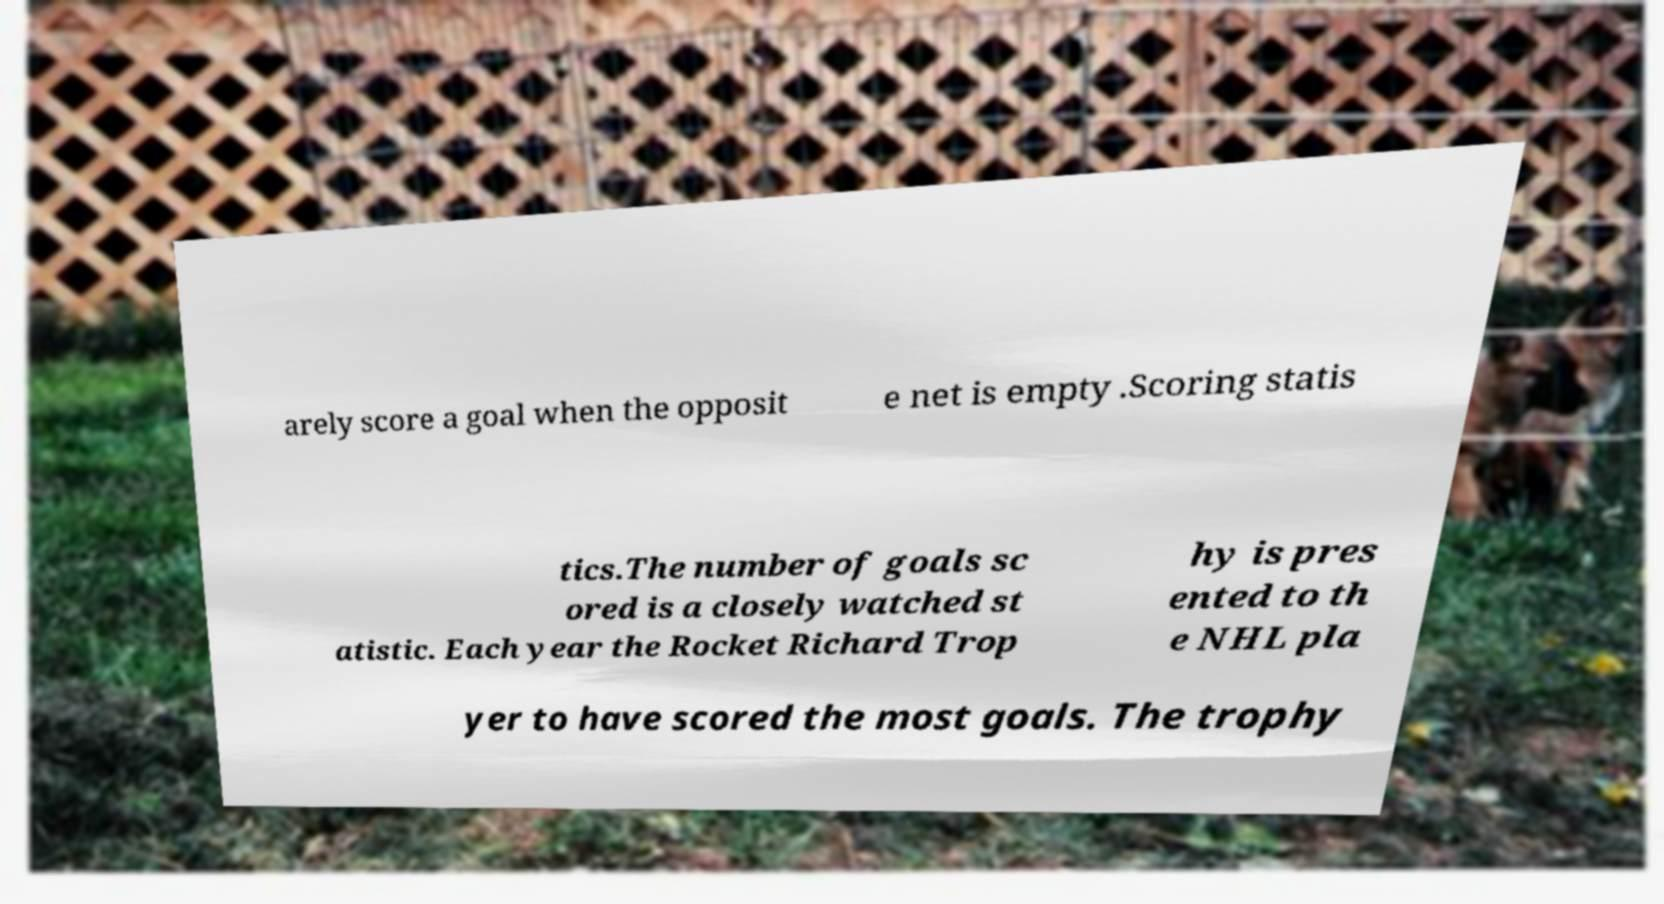There's text embedded in this image that I need extracted. Can you transcribe it verbatim? arely score a goal when the opposit e net is empty .Scoring statis tics.The number of goals sc ored is a closely watched st atistic. Each year the Rocket Richard Trop hy is pres ented to th e NHL pla yer to have scored the most goals. The trophy 